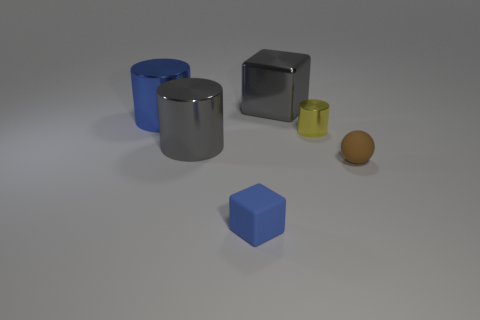There is a metallic object that is the same color as the small block; what is its size?
Keep it short and to the point. Large. What number of small rubber balls have the same color as the big metallic cube?
Provide a short and direct response. 0. What is the shape of the blue matte object?
Your answer should be compact. Cube. There is a cylinder that is both behind the gray cylinder and right of the blue cylinder; what color is it?
Give a very brief answer. Yellow. What is the material of the large gray block?
Offer a very short reply. Metal. There is a blue thing in front of the small matte ball; what is its shape?
Ensure brevity in your answer.  Cube. There is another shiny cylinder that is the same size as the blue cylinder; what color is it?
Give a very brief answer. Gray. Is the large gray object that is in front of the metal cube made of the same material as the large blue object?
Your answer should be compact. Yes. What is the size of the thing that is both on the right side of the tiny blue rubber cube and in front of the small yellow cylinder?
Offer a terse response. Small. There is a block that is in front of the large cube; what size is it?
Your answer should be compact. Small. 